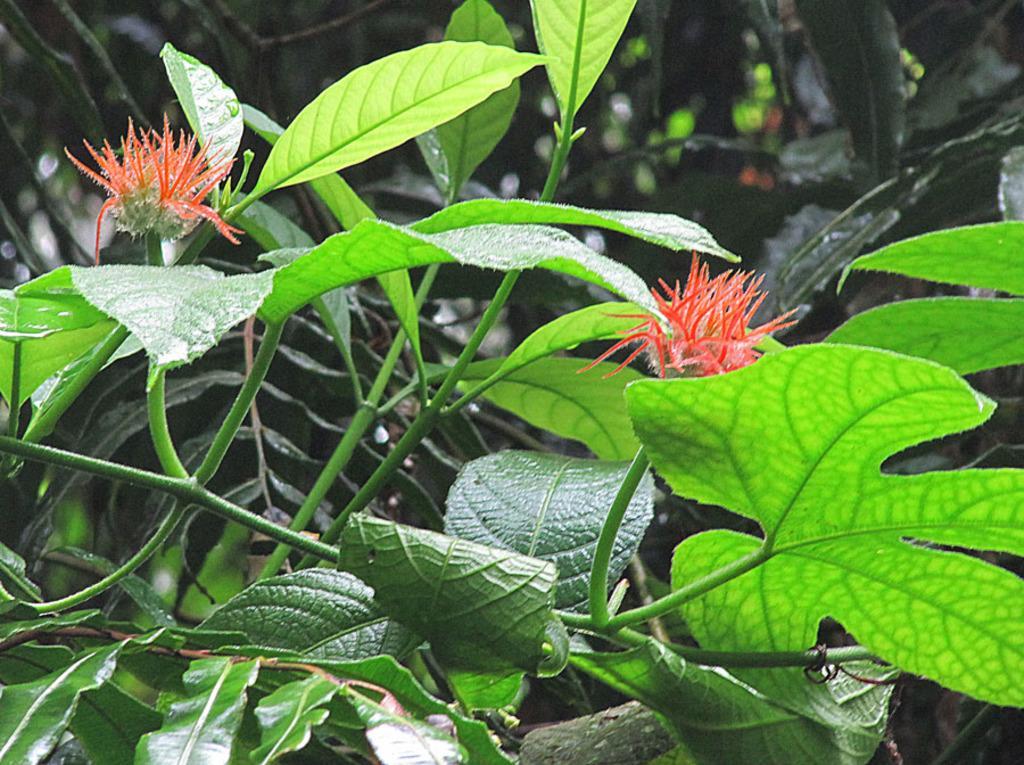How would you summarize this image in a sentence or two? In this picture I can see there is a plant and it has few flowers and the backdrop is blurred. 